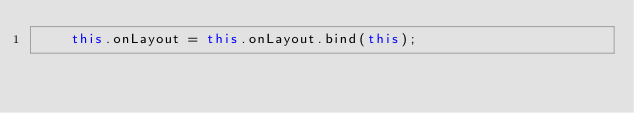<code> <loc_0><loc_0><loc_500><loc_500><_TypeScript_>    this.onLayout = this.onLayout.bind(this);</code> 